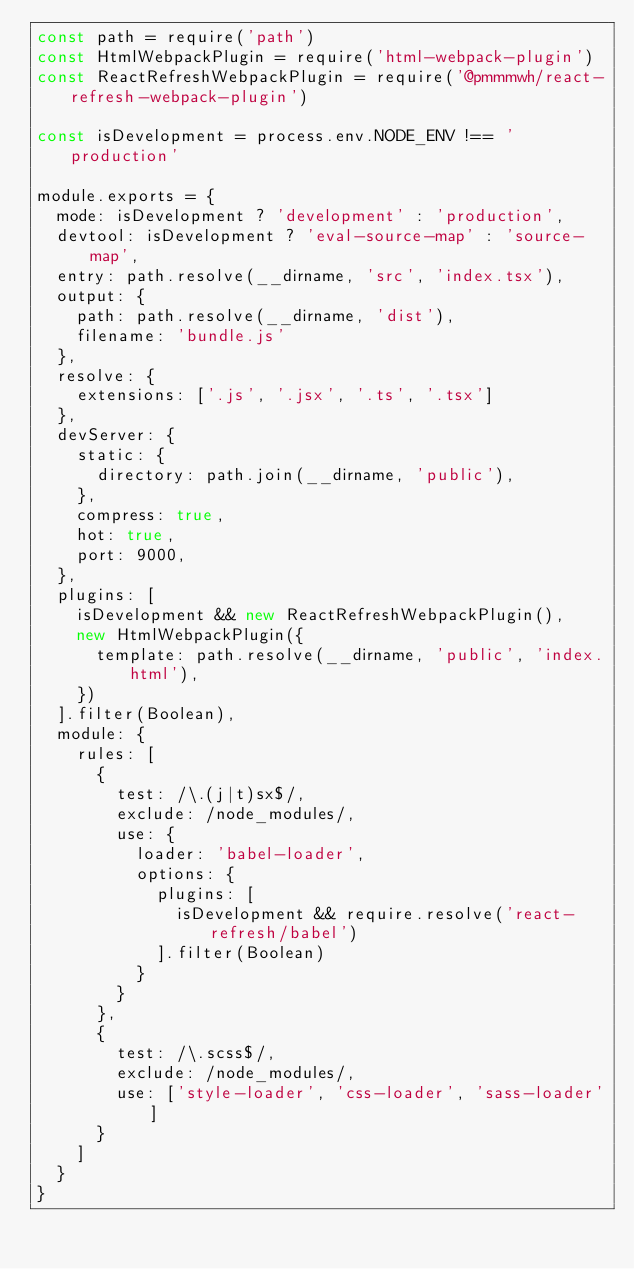Convert code to text. <code><loc_0><loc_0><loc_500><loc_500><_JavaScript_>const path = require('path')
const HtmlWebpackPlugin = require('html-webpack-plugin')
const ReactRefreshWebpackPlugin = require('@pmmmwh/react-refresh-webpack-plugin')

const isDevelopment = process.env.NODE_ENV !== 'production'

module.exports = {
  mode: isDevelopment ? 'development' : 'production',
  devtool: isDevelopment ? 'eval-source-map' : 'source-map',
  entry: path.resolve(__dirname, 'src', 'index.tsx'),
  output: {
    path: path.resolve(__dirname, 'dist'),
    filename: 'bundle.js'
  },
  resolve: {
    extensions: ['.js', '.jsx', '.ts', '.tsx']
  },
  devServer: {
    static: {
      directory: path.join(__dirname, 'public'),
    },
    compress: true,
    hot: true,
    port: 9000,
  },
  plugins: [
    isDevelopment && new ReactRefreshWebpackPlugin(),
    new HtmlWebpackPlugin({
      template: path.resolve(__dirname, 'public', 'index.html'),
    })
  ].filter(Boolean),
  module: {
    rules: [
      { 
        test: /\.(j|t)sx$/,
        exclude: /node_modules/,
        use: {
          loader: 'babel-loader',
          options: {
            plugins: [
              isDevelopment && require.resolve('react-refresh/babel')
            ].filter(Boolean)
          }
        }
      },
      { 
        test: /\.scss$/,
        exclude: /node_modules/,
        use: ['style-loader', 'css-loader', 'sass-loader']
      }
    ]
  }
}</code> 